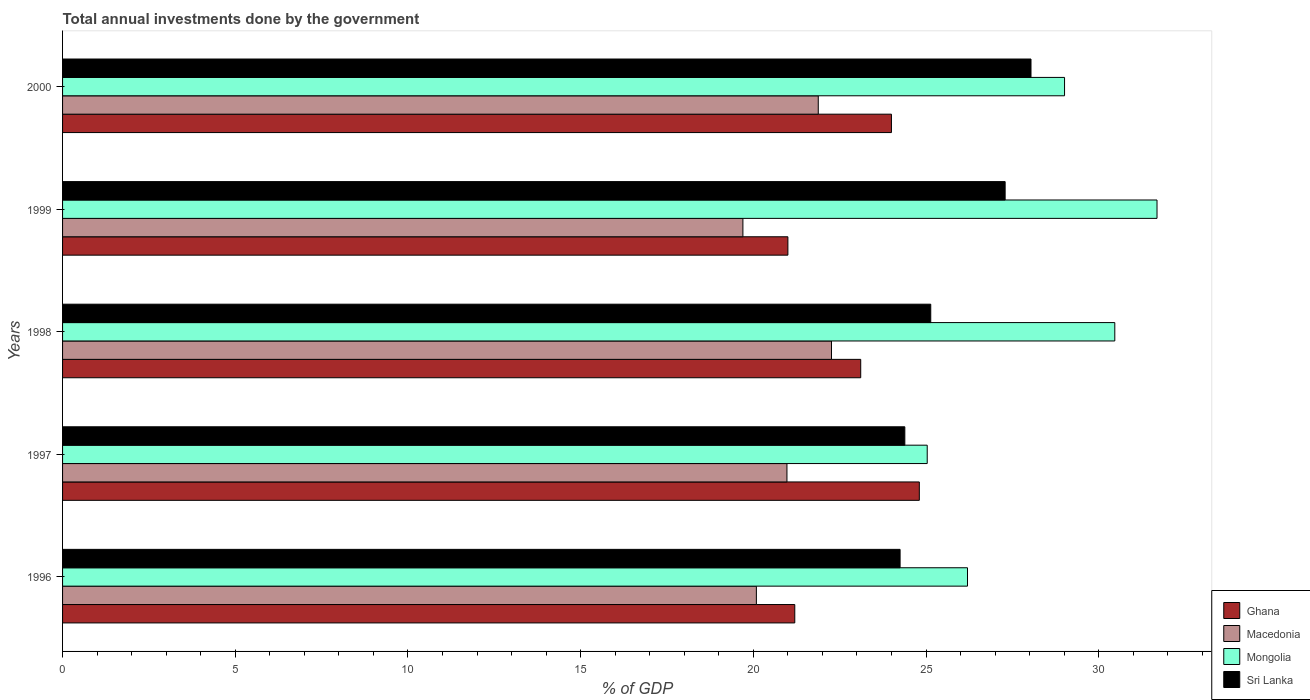How many groups of bars are there?
Your answer should be compact. 5. How many bars are there on the 3rd tick from the top?
Keep it short and to the point. 4. How many bars are there on the 1st tick from the bottom?
Make the answer very short. 4. What is the label of the 2nd group of bars from the top?
Your answer should be very brief. 1999. What is the total annual investments done by the government in Sri Lanka in 1998?
Your answer should be compact. 25.14. Across all years, what is the maximum total annual investments done by the government in Mongolia?
Make the answer very short. 31.69. Across all years, what is the minimum total annual investments done by the government in Macedonia?
Provide a short and direct response. 19.7. In which year was the total annual investments done by the government in Ghana minimum?
Offer a very short reply. 1999. What is the total total annual investments done by the government in Sri Lanka in the graph?
Ensure brevity in your answer.  129.1. What is the difference between the total annual investments done by the government in Macedonia in 1997 and that in 2000?
Keep it short and to the point. -0.91. What is the difference between the total annual investments done by the government in Sri Lanka in 2000 and the total annual investments done by the government in Macedonia in 1997?
Your response must be concise. 7.07. What is the average total annual investments done by the government in Mongolia per year?
Your answer should be compact. 28.48. In the year 2000, what is the difference between the total annual investments done by the government in Sri Lanka and total annual investments done by the government in Mongolia?
Your answer should be very brief. -0.97. What is the ratio of the total annual investments done by the government in Ghana in 1996 to that in 2000?
Offer a terse response. 0.88. What is the difference between the highest and the second highest total annual investments done by the government in Mongolia?
Offer a very short reply. 1.22. What is the difference between the highest and the lowest total annual investments done by the government in Ghana?
Your answer should be very brief. 3.81. Is it the case that in every year, the sum of the total annual investments done by the government in Mongolia and total annual investments done by the government in Macedonia is greater than the sum of total annual investments done by the government in Sri Lanka and total annual investments done by the government in Ghana?
Your answer should be compact. No. What does the 4th bar from the top in 1999 represents?
Your answer should be very brief. Ghana. What does the 4th bar from the bottom in 1996 represents?
Give a very brief answer. Sri Lanka. Is it the case that in every year, the sum of the total annual investments done by the government in Ghana and total annual investments done by the government in Sri Lanka is greater than the total annual investments done by the government in Mongolia?
Give a very brief answer. Yes. Are all the bars in the graph horizontal?
Provide a short and direct response. Yes. What is the difference between two consecutive major ticks on the X-axis?
Your answer should be very brief. 5. Are the values on the major ticks of X-axis written in scientific E-notation?
Your answer should be very brief. No. Does the graph contain grids?
Provide a succinct answer. No. How many legend labels are there?
Your response must be concise. 4. What is the title of the graph?
Provide a short and direct response. Total annual investments done by the government. What is the label or title of the X-axis?
Make the answer very short. % of GDP. What is the % of GDP in Ghana in 1996?
Make the answer very short. 21.2. What is the % of GDP in Macedonia in 1996?
Offer a terse response. 20.09. What is the % of GDP in Mongolia in 1996?
Provide a succinct answer. 26.2. What is the % of GDP of Sri Lanka in 1996?
Your response must be concise. 24.25. What is the % of GDP of Ghana in 1997?
Provide a succinct answer. 24.81. What is the % of GDP in Macedonia in 1997?
Your response must be concise. 20.97. What is the % of GDP in Mongolia in 1997?
Your answer should be compact. 25.03. What is the % of GDP of Sri Lanka in 1997?
Give a very brief answer. 24.39. What is the % of GDP of Ghana in 1998?
Provide a succinct answer. 23.11. What is the % of GDP of Macedonia in 1998?
Your response must be concise. 22.26. What is the % of GDP in Mongolia in 1998?
Your answer should be compact. 30.47. What is the % of GDP in Sri Lanka in 1998?
Provide a succinct answer. 25.14. What is the % of GDP of Ghana in 1999?
Give a very brief answer. 21. What is the % of GDP in Macedonia in 1999?
Your response must be concise. 19.7. What is the % of GDP in Mongolia in 1999?
Offer a very short reply. 31.69. What is the % of GDP in Sri Lanka in 1999?
Offer a very short reply. 27.29. What is the % of GDP in Ghana in 2000?
Make the answer very short. 24. What is the % of GDP in Macedonia in 2000?
Provide a short and direct response. 21.88. What is the % of GDP of Mongolia in 2000?
Make the answer very short. 29.01. What is the % of GDP in Sri Lanka in 2000?
Provide a short and direct response. 28.04. Across all years, what is the maximum % of GDP of Ghana?
Provide a succinct answer. 24.81. Across all years, what is the maximum % of GDP in Macedonia?
Ensure brevity in your answer.  22.26. Across all years, what is the maximum % of GDP of Mongolia?
Make the answer very short. 31.69. Across all years, what is the maximum % of GDP of Sri Lanka?
Offer a very short reply. 28.04. Across all years, what is the minimum % of GDP in Ghana?
Your answer should be compact. 21. Across all years, what is the minimum % of GDP of Macedonia?
Ensure brevity in your answer.  19.7. Across all years, what is the minimum % of GDP in Mongolia?
Your answer should be compact. 25.03. Across all years, what is the minimum % of GDP in Sri Lanka?
Provide a short and direct response. 24.25. What is the total % of GDP in Ghana in the graph?
Provide a succinct answer. 114.11. What is the total % of GDP of Macedonia in the graph?
Keep it short and to the point. 104.9. What is the total % of GDP in Mongolia in the graph?
Provide a short and direct response. 142.4. What is the total % of GDP of Sri Lanka in the graph?
Keep it short and to the point. 129.1. What is the difference between the % of GDP in Ghana in 1996 and that in 1997?
Offer a terse response. -3.61. What is the difference between the % of GDP of Macedonia in 1996 and that in 1997?
Ensure brevity in your answer.  -0.89. What is the difference between the % of GDP of Mongolia in 1996 and that in 1997?
Give a very brief answer. 1.17. What is the difference between the % of GDP in Sri Lanka in 1996 and that in 1997?
Keep it short and to the point. -0.14. What is the difference between the % of GDP in Ghana in 1996 and that in 1998?
Keep it short and to the point. -1.91. What is the difference between the % of GDP of Macedonia in 1996 and that in 1998?
Offer a very short reply. -2.17. What is the difference between the % of GDP of Mongolia in 1996 and that in 1998?
Your response must be concise. -4.26. What is the difference between the % of GDP in Sri Lanka in 1996 and that in 1998?
Your answer should be very brief. -0.89. What is the difference between the % of GDP in Ghana in 1996 and that in 1999?
Your answer should be very brief. 0.2. What is the difference between the % of GDP of Macedonia in 1996 and that in 1999?
Give a very brief answer. 0.39. What is the difference between the % of GDP in Mongolia in 1996 and that in 1999?
Your answer should be very brief. -5.49. What is the difference between the % of GDP of Sri Lanka in 1996 and that in 1999?
Offer a very short reply. -3.04. What is the difference between the % of GDP of Ghana in 1996 and that in 2000?
Your answer should be compact. -2.8. What is the difference between the % of GDP of Macedonia in 1996 and that in 2000?
Provide a succinct answer. -1.79. What is the difference between the % of GDP of Mongolia in 1996 and that in 2000?
Keep it short and to the point. -2.81. What is the difference between the % of GDP in Sri Lanka in 1996 and that in 2000?
Offer a terse response. -3.79. What is the difference between the % of GDP of Ghana in 1997 and that in 1998?
Provide a short and direct response. 1.7. What is the difference between the % of GDP of Macedonia in 1997 and that in 1998?
Offer a very short reply. -1.29. What is the difference between the % of GDP of Mongolia in 1997 and that in 1998?
Give a very brief answer. -5.43. What is the difference between the % of GDP in Sri Lanka in 1997 and that in 1998?
Give a very brief answer. -0.75. What is the difference between the % of GDP of Ghana in 1997 and that in 1999?
Provide a short and direct response. 3.81. What is the difference between the % of GDP of Macedonia in 1997 and that in 1999?
Give a very brief answer. 1.28. What is the difference between the % of GDP of Mongolia in 1997 and that in 1999?
Keep it short and to the point. -6.65. What is the difference between the % of GDP of Sri Lanka in 1997 and that in 1999?
Ensure brevity in your answer.  -2.9. What is the difference between the % of GDP of Ghana in 1997 and that in 2000?
Your answer should be compact. 0.81. What is the difference between the % of GDP of Macedonia in 1997 and that in 2000?
Offer a very short reply. -0.91. What is the difference between the % of GDP of Mongolia in 1997 and that in 2000?
Your answer should be very brief. -3.98. What is the difference between the % of GDP in Sri Lanka in 1997 and that in 2000?
Your answer should be very brief. -3.65. What is the difference between the % of GDP of Ghana in 1998 and that in 1999?
Give a very brief answer. 2.11. What is the difference between the % of GDP of Macedonia in 1998 and that in 1999?
Keep it short and to the point. 2.56. What is the difference between the % of GDP in Mongolia in 1998 and that in 1999?
Keep it short and to the point. -1.22. What is the difference between the % of GDP of Sri Lanka in 1998 and that in 1999?
Your answer should be compact. -2.15. What is the difference between the % of GDP of Ghana in 1998 and that in 2000?
Your answer should be compact. -0.89. What is the difference between the % of GDP of Macedonia in 1998 and that in 2000?
Your response must be concise. 0.38. What is the difference between the % of GDP in Mongolia in 1998 and that in 2000?
Ensure brevity in your answer.  1.45. What is the difference between the % of GDP in Sri Lanka in 1998 and that in 2000?
Provide a short and direct response. -2.9. What is the difference between the % of GDP in Ghana in 1999 and that in 2000?
Provide a succinct answer. -3. What is the difference between the % of GDP of Macedonia in 1999 and that in 2000?
Provide a succinct answer. -2.18. What is the difference between the % of GDP of Mongolia in 1999 and that in 2000?
Make the answer very short. 2.68. What is the difference between the % of GDP of Sri Lanka in 1999 and that in 2000?
Offer a very short reply. -0.75. What is the difference between the % of GDP in Ghana in 1996 and the % of GDP in Macedonia in 1997?
Offer a very short reply. 0.23. What is the difference between the % of GDP in Ghana in 1996 and the % of GDP in Mongolia in 1997?
Make the answer very short. -3.83. What is the difference between the % of GDP of Ghana in 1996 and the % of GDP of Sri Lanka in 1997?
Your answer should be compact. -3.19. What is the difference between the % of GDP in Macedonia in 1996 and the % of GDP in Mongolia in 1997?
Your answer should be very brief. -4.95. What is the difference between the % of GDP in Macedonia in 1996 and the % of GDP in Sri Lanka in 1997?
Give a very brief answer. -4.3. What is the difference between the % of GDP of Mongolia in 1996 and the % of GDP of Sri Lanka in 1997?
Keep it short and to the point. 1.81. What is the difference between the % of GDP of Ghana in 1996 and the % of GDP of Macedonia in 1998?
Your answer should be very brief. -1.06. What is the difference between the % of GDP of Ghana in 1996 and the % of GDP of Mongolia in 1998?
Your answer should be compact. -9.27. What is the difference between the % of GDP in Ghana in 1996 and the % of GDP in Sri Lanka in 1998?
Offer a very short reply. -3.94. What is the difference between the % of GDP of Macedonia in 1996 and the % of GDP of Mongolia in 1998?
Your answer should be very brief. -10.38. What is the difference between the % of GDP in Macedonia in 1996 and the % of GDP in Sri Lanka in 1998?
Provide a short and direct response. -5.05. What is the difference between the % of GDP of Mongolia in 1996 and the % of GDP of Sri Lanka in 1998?
Offer a very short reply. 1.06. What is the difference between the % of GDP in Ghana in 1996 and the % of GDP in Macedonia in 1999?
Offer a very short reply. 1.5. What is the difference between the % of GDP in Ghana in 1996 and the % of GDP in Mongolia in 1999?
Your answer should be compact. -10.49. What is the difference between the % of GDP of Ghana in 1996 and the % of GDP of Sri Lanka in 1999?
Ensure brevity in your answer.  -6.09. What is the difference between the % of GDP in Macedonia in 1996 and the % of GDP in Sri Lanka in 1999?
Offer a very short reply. -7.2. What is the difference between the % of GDP in Mongolia in 1996 and the % of GDP in Sri Lanka in 1999?
Your answer should be very brief. -1.09. What is the difference between the % of GDP in Ghana in 1996 and the % of GDP in Macedonia in 2000?
Your answer should be compact. -0.68. What is the difference between the % of GDP of Ghana in 1996 and the % of GDP of Mongolia in 2000?
Give a very brief answer. -7.81. What is the difference between the % of GDP in Ghana in 1996 and the % of GDP in Sri Lanka in 2000?
Ensure brevity in your answer.  -6.84. What is the difference between the % of GDP in Macedonia in 1996 and the % of GDP in Mongolia in 2000?
Your answer should be compact. -8.92. What is the difference between the % of GDP of Macedonia in 1996 and the % of GDP of Sri Lanka in 2000?
Your response must be concise. -7.95. What is the difference between the % of GDP in Mongolia in 1996 and the % of GDP in Sri Lanka in 2000?
Keep it short and to the point. -1.84. What is the difference between the % of GDP of Ghana in 1997 and the % of GDP of Macedonia in 1998?
Give a very brief answer. 2.54. What is the difference between the % of GDP in Ghana in 1997 and the % of GDP in Mongolia in 1998?
Offer a very short reply. -5.66. What is the difference between the % of GDP of Ghana in 1997 and the % of GDP of Sri Lanka in 1998?
Your response must be concise. -0.33. What is the difference between the % of GDP in Macedonia in 1997 and the % of GDP in Mongolia in 1998?
Offer a terse response. -9.49. What is the difference between the % of GDP of Macedonia in 1997 and the % of GDP of Sri Lanka in 1998?
Make the answer very short. -4.16. What is the difference between the % of GDP of Mongolia in 1997 and the % of GDP of Sri Lanka in 1998?
Offer a very short reply. -0.1. What is the difference between the % of GDP of Ghana in 1997 and the % of GDP of Macedonia in 1999?
Ensure brevity in your answer.  5.11. What is the difference between the % of GDP in Ghana in 1997 and the % of GDP in Mongolia in 1999?
Provide a succinct answer. -6.88. What is the difference between the % of GDP of Ghana in 1997 and the % of GDP of Sri Lanka in 1999?
Your response must be concise. -2.48. What is the difference between the % of GDP of Macedonia in 1997 and the % of GDP of Mongolia in 1999?
Your answer should be compact. -10.71. What is the difference between the % of GDP in Macedonia in 1997 and the % of GDP in Sri Lanka in 1999?
Offer a terse response. -6.32. What is the difference between the % of GDP of Mongolia in 1997 and the % of GDP of Sri Lanka in 1999?
Your answer should be very brief. -2.26. What is the difference between the % of GDP of Ghana in 1997 and the % of GDP of Macedonia in 2000?
Provide a succinct answer. 2.93. What is the difference between the % of GDP in Ghana in 1997 and the % of GDP in Mongolia in 2000?
Your response must be concise. -4.2. What is the difference between the % of GDP of Ghana in 1997 and the % of GDP of Sri Lanka in 2000?
Give a very brief answer. -3.23. What is the difference between the % of GDP in Macedonia in 1997 and the % of GDP in Mongolia in 2000?
Offer a very short reply. -8.04. What is the difference between the % of GDP in Macedonia in 1997 and the % of GDP in Sri Lanka in 2000?
Your answer should be very brief. -7.07. What is the difference between the % of GDP in Mongolia in 1997 and the % of GDP in Sri Lanka in 2000?
Provide a succinct answer. -3. What is the difference between the % of GDP of Ghana in 1998 and the % of GDP of Macedonia in 1999?
Make the answer very short. 3.41. What is the difference between the % of GDP of Ghana in 1998 and the % of GDP of Mongolia in 1999?
Your answer should be compact. -8.58. What is the difference between the % of GDP in Ghana in 1998 and the % of GDP in Sri Lanka in 1999?
Your response must be concise. -4.18. What is the difference between the % of GDP of Macedonia in 1998 and the % of GDP of Mongolia in 1999?
Your response must be concise. -9.43. What is the difference between the % of GDP in Macedonia in 1998 and the % of GDP in Sri Lanka in 1999?
Your answer should be compact. -5.03. What is the difference between the % of GDP of Mongolia in 1998 and the % of GDP of Sri Lanka in 1999?
Your answer should be very brief. 3.17. What is the difference between the % of GDP of Ghana in 1998 and the % of GDP of Macedonia in 2000?
Your response must be concise. 1.23. What is the difference between the % of GDP in Ghana in 1998 and the % of GDP in Mongolia in 2000?
Give a very brief answer. -5.9. What is the difference between the % of GDP of Ghana in 1998 and the % of GDP of Sri Lanka in 2000?
Provide a succinct answer. -4.93. What is the difference between the % of GDP of Macedonia in 1998 and the % of GDP of Mongolia in 2000?
Your answer should be compact. -6.75. What is the difference between the % of GDP in Macedonia in 1998 and the % of GDP in Sri Lanka in 2000?
Offer a terse response. -5.78. What is the difference between the % of GDP in Mongolia in 1998 and the % of GDP in Sri Lanka in 2000?
Make the answer very short. 2.43. What is the difference between the % of GDP in Ghana in 1999 and the % of GDP in Macedonia in 2000?
Give a very brief answer. -0.88. What is the difference between the % of GDP in Ghana in 1999 and the % of GDP in Mongolia in 2000?
Your response must be concise. -8.01. What is the difference between the % of GDP of Ghana in 1999 and the % of GDP of Sri Lanka in 2000?
Offer a terse response. -7.04. What is the difference between the % of GDP in Macedonia in 1999 and the % of GDP in Mongolia in 2000?
Make the answer very short. -9.31. What is the difference between the % of GDP in Macedonia in 1999 and the % of GDP in Sri Lanka in 2000?
Give a very brief answer. -8.34. What is the difference between the % of GDP of Mongolia in 1999 and the % of GDP of Sri Lanka in 2000?
Offer a very short reply. 3.65. What is the average % of GDP of Ghana per year?
Give a very brief answer. 22.82. What is the average % of GDP in Macedonia per year?
Give a very brief answer. 20.98. What is the average % of GDP of Mongolia per year?
Provide a succinct answer. 28.48. What is the average % of GDP of Sri Lanka per year?
Keep it short and to the point. 25.82. In the year 1996, what is the difference between the % of GDP in Ghana and % of GDP in Macedonia?
Keep it short and to the point. 1.11. In the year 1996, what is the difference between the % of GDP of Ghana and % of GDP of Mongolia?
Offer a terse response. -5. In the year 1996, what is the difference between the % of GDP of Ghana and % of GDP of Sri Lanka?
Make the answer very short. -3.05. In the year 1996, what is the difference between the % of GDP in Macedonia and % of GDP in Mongolia?
Make the answer very short. -6.11. In the year 1996, what is the difference between the % of GDP of Macedonia and % of GDP of Sri Lanka?
Provide a succinct answer. -4.16. In the year 1996, what is the difference between the % of GDP in Mongolia and % of GDP in Sri Lanka?
Keep it short and to the point. 1.95. In the year 1997, what is the difference between the % of GDP in Ghana and % of GDP in Macedonia?
Provide a short and direct response. 3.83. In the year 1997, what is the difference between the % of GDP of Ghana and % of GDP of Mongolia?
Make the answer very short. -0.23. In the year 1997, what is the difference between the % of GDP in Ghana and % of GDP in Sri Lanka?
Your answer should be very brief. 0.42. In the year 1997, what is the difference between the % of GDP of Macedonia and % of GDP of Mongolia?
Your answer should be very brief. -4.06. In the year 1997, what is the difference between the % of GDP in Macedonia and % of GDP in Sri Lanka?
Offer a very short reply. -3.41. In the year 1997, what is the difference between the % of GDP in Mongolia and % of GDP in Sri Lanka?
Give a very brief answer. 0.65. In the year 1998, what is the difference between the % of GDP in Ghana and % of GDP in Macedonia?
Offer a terse response. 0.85. In the year 1998, what is the difference between the % of GDP in Ghana and % of GDP in Mongolia?
Make the answer very short. -7.36. In the year 1998, what is the difference between the % of GDP in Ghana and % of GDP in Sri Lanka?
Provide a short and direct response. -2.03. In the year 1998, what is the difference between the % of GDP in Macedonia and % of GDP in Mongolia?
Ensure brevity in your answer.  -8.2. In the year 1998, what is the difference between the % of GDP of Macedonia and % of GDP of Sri Lanka?
Provide a succinct answer. -2.87. In the year 1998, what is the difference between the % of GDP of Mongolia and % of GDP of Sri Lanka?
Provide a succinct answer. 5.33. In the year 1999, what is the difference between the % of GDP of Ghana and % of GDP of Macedonia?
Offer a terse response. 1.3. In the year 1999, what is the difference between the % of GDP of Ghana and % of GDP of Mongolia?
Give a very brief answer. -10.69. In the year 1999, what is the difference between the % of GDP of Ghana and % of GDP of Sri Lanka?
Make the answer very short. -6.29. In the year 1999, what is the difference between the % of GDP in Macedonia and % of GDP in Mongolia?
Your response must be concise. -11.99. In the year 1999, what is the difference between the % of GDP of Macedonia and % of GDP of Sri Lanka?
Your answer should be compact. -7.59. In the year 1999, what is the difference between the % of GDP of Mongolia and % of GDP of Sri Lanka?
Offer a very short reply. 4.4. In the year 2000, what is the difference between the % of GDP of Ghana and % of GDP of Macedonia?
Offer a very short reply. 2.12. In the year 2000, what is the difference between the % of GDP in Ghana and % of GDP in Mongolia?
Your answer should be very brief. -5.01. In the year 2000, what is the difference between the % of GDP in Ghana and % of GDP in Sri Lanka?
Ensure brevity in your answer.  -4.04. In the year 2000, what is the difference between the % of GDP of Macedonia and % of GDP of Mongolia?
Make the answer very short. -7.13. In the year 2000, what is the difference between the % of GDP of Macedonia and % of GDP of Sri Lanka?
Your answer should be compact. -6.16. In the year 2000, what is the difference between the % of GDP in Mongolia and % of GDP in Sri Lanka?
Keep it short and to the point. 0.97. What is the ratio of the % of GDP of Ghana in 1996 to that in 1997?
Make the answer very short. 0.85. What is the ratio of the % of GDP in Macedonia in 1996 to that in 1997?
Offer a terse response. 0.96. What is the ratio of the % of GDP in Mongolia in 1996 to that in 1997?
Offer a very short reply. 1.05. What is the ratio of the % of GDP of Ghana in 1996 to that in 1998?
Offer a very short reply. 0.92. What is the ratio of the % of GDP of Macedonia in 1996 to that in 1998?
Provide a succinct answer. 0.9. What is the ratio of the % of GDP of Mongolia in 1996 to that in 1998?
Your answer should be very brief. 0.86. What is the ratio of the % of GDP in Sri Lanka in 1996 to that in 1998?
Offer a terse response. 0.96. What is the ratio of the % of GDP of Ghana in 1996 to that in 1999?
Your answer should be very brief. 1.01. What is the ratio of the % of GDP in Macedonia in 1996 to that in 1999?
Ensure brevity in your answer.  1.02. What is the ratio of the % of GDP in Mongolia in 1996 to that in 1999?
Give a very brief answer. 0.83. What is the ratio of the % of GDP of Sri Lanka in 1996 to that in 1999?
Your response must be concise. 0.89. What is the ratio of the % of GDP of Ghana in 1996 to that in 2000?
Your response must be concise. 0.88. What is the ratio of the % of GDP in Macedonia in 1996 to that in 2000?
Your answer should be compact. 0.92. What is the ratio of the % of GDP in Mongolia in 1996 to that in 2000?
Your answer should be compact. 0.9. What is the ratio of the % of GDP of Sri Lanka in 1996 to that in 2000?
Your answer should be very brief. 0.86. What is the ratio of the % of GDP in Ghana in 1997 to that in 1998?
Give a very brief answer. 1.07. What is the ratio of the % of GDP in Macedonia in 1997 to that in 1998?
Offer a very short reply. 0.94. What is the ratio of the % of GDP of Mongolia in 1997 to that in 1998?
Ensure brevity in your answer.  0.82. What is the ratio of the % of GDP of Sri Lanka in 1997 to that in 1998?
Provide a succinct answer. 0.97. What is the ratio of the % of GDP of Ghana in 1997 to that in 1999?
Ensure brevity in your answer.  1.18. What is the ratio of the % of GDP in Macedonia in 1997 to that in 1999?
Your answer should be very brief. 1.06. What is the ratio of the % of GDP in Mongolia in 1997 to that in 1999?
Your answer should be very brief. 0.79. What is the ratio of the % of GDP in Sri Lanka in 1997 to that in 1999?
Give a very brief answer. 0.89. What is the ratio of the % of GDP of Ghana in 1997 to that in 2000?
Keep it short and to the point. 1.03. What is the ratio of the % of GDP in Macedonia in 1997 to that in 2000?
Your response must be concise. 0.96. What is the ratio of the % of GDP of Mongolia in 1997 to that in 2000?
Offer a terse response. 0.86. What is the ratio of the % of GDP of Sri Lanka in 1997 to that in 2000?
Your answer should be compact. 0.87. What is the ratio of the % of GDP in Ghana in 1998 to that in 1999?
Ensure brevity in your answer.  1.1. What is the ratio of the % of GDP of Macedonia in 1998 to that in 1999?
Give a very brief answer. 1.13. What is the ratio of the % of GDP of Mongolia in 1998 to that in 1999?
Provide a short and direct response. 0.96. What is the ratio of the % of GDP of Sri Lanka in 1998 to that in 1999?
Your answer should be very brief. 0.92. What is the ratio of the % of GDP of Ghana in 1998 to that in 2000?
Give a very brief answer. 0.96. What is the ratio of the % of GDP in Macedonia in 1998 to that in 2000?
Ensure brevity in your answer.  1.02. What is the ratio of the % of GDP of Mongolia in 1998 to that in 2000?
Make the answer very short. 1.05. What is the ratio of the % of GDP of Sri Lanka in 1998 to that in 2000?
Your answer should be compact. 0.9. What is the ratio of the % of GDP of Ghana in 1999 to that in 2000?
Offer a terse response. 0.88. What is the ratio of the % of GDP in Macedonia in 1999 to that in 2000?
Provide a succinct answer. 0.9. What is the ratio of the % of GDP of Mongolia in 1999 to that in 2000?
Provide a succinct answer. 1.09. What is the ratio of the % of GDP in Sri Lanka in 1999 to that in 2000?
Keep it short and to the point. 0.97. What is the difference between the highest and the second highest % of GDP in Ghana?
Provide a succinct answer. 0.81. What is the difference between the highest and the second highest % of GDP of Macedonia?
Your response must be concise. 0.38. What is the difference between the highest and the second highest % of GDP in Mongolia?
Ensure brevity in your answer.  1.22. What is the difference between the highest and the second highest % of GDP in Sri Lanka?
Your response must be concise. 0.75. What is the difference between the highest and the lowest % of GDP in Ghana?
Offer a very short reply. 3.81. What is the difference between the highest and the lowest % of GDP of Macedonia?
Provide a succinct answer. 2.56. What is the difference between the highest and the lowest % of GDP of Mongolia?
Make the answer very short. 6.65. What is the difference between the highest and the lowest % of GDP in Sri Lanka?
Provide a short and direct response. 3.79. 